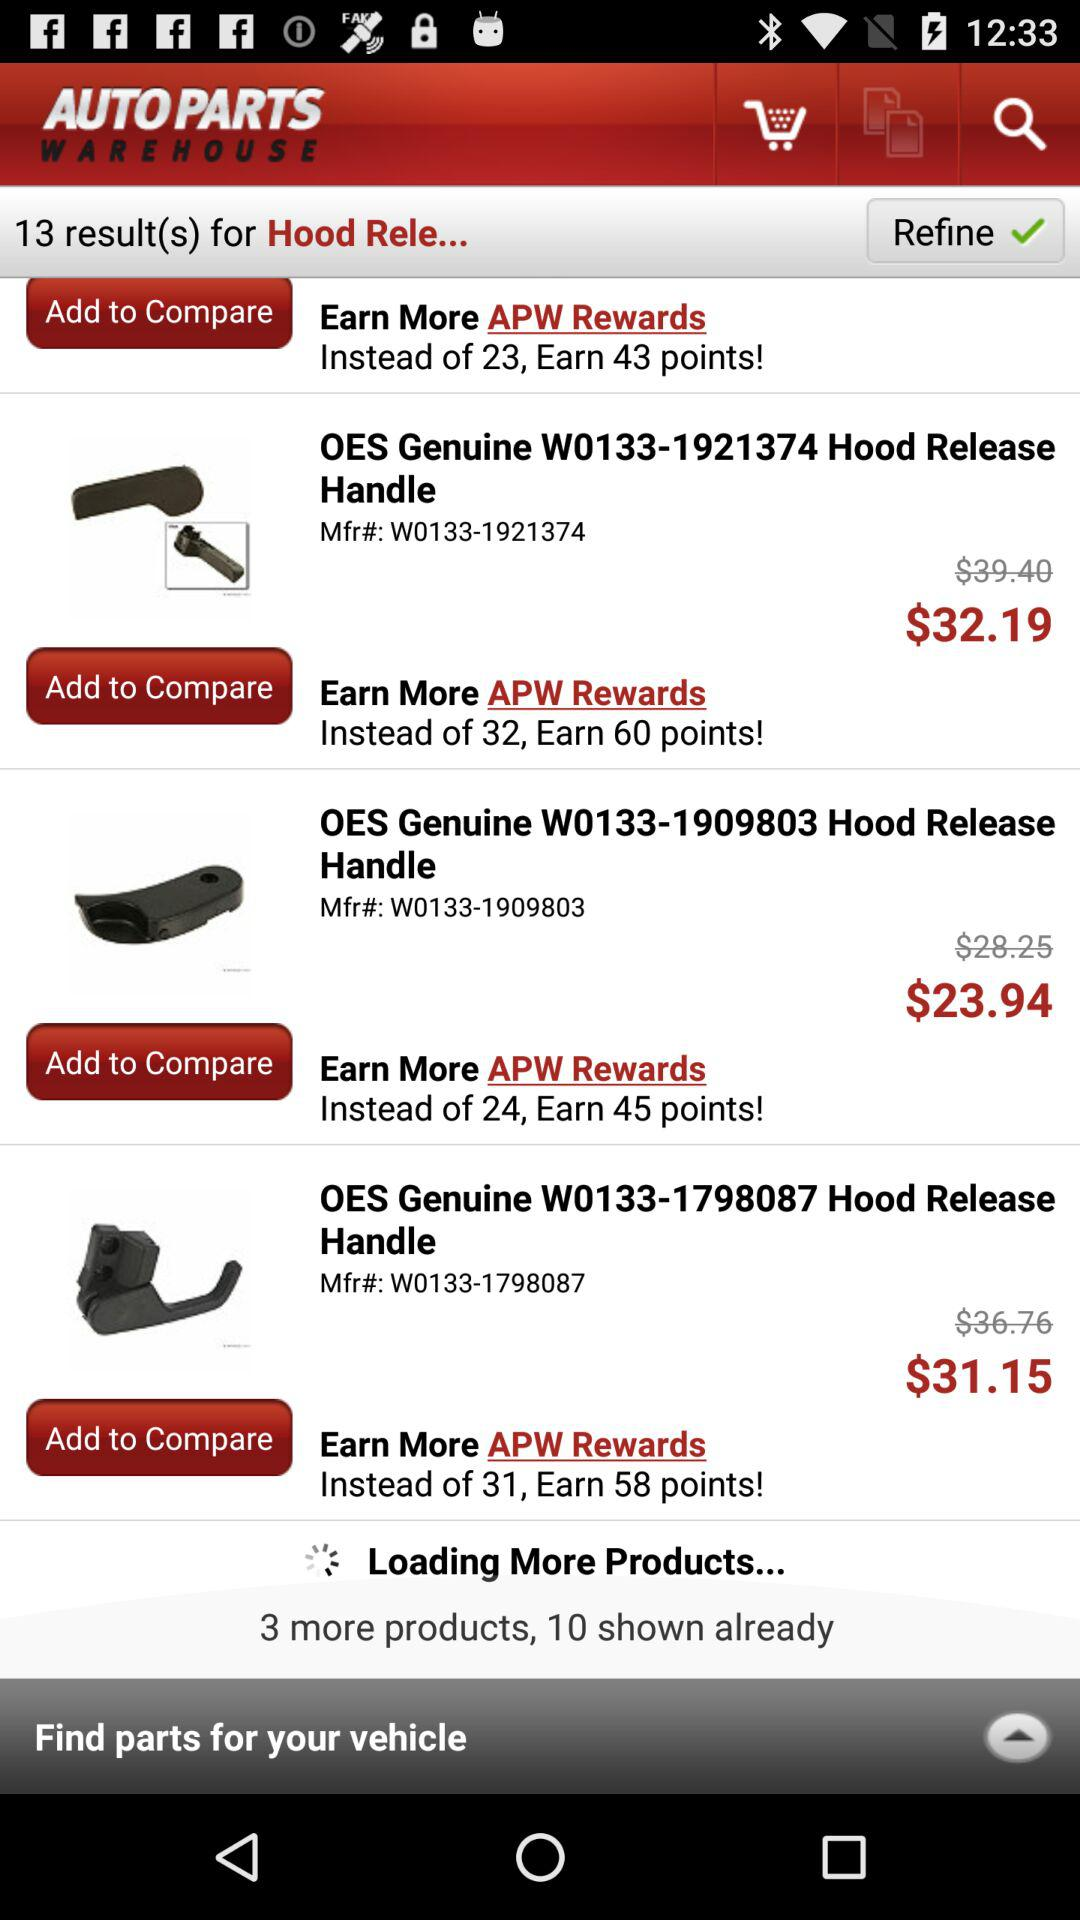What is the price of the item having the model number W0133-1798087? The price is $31.15. 